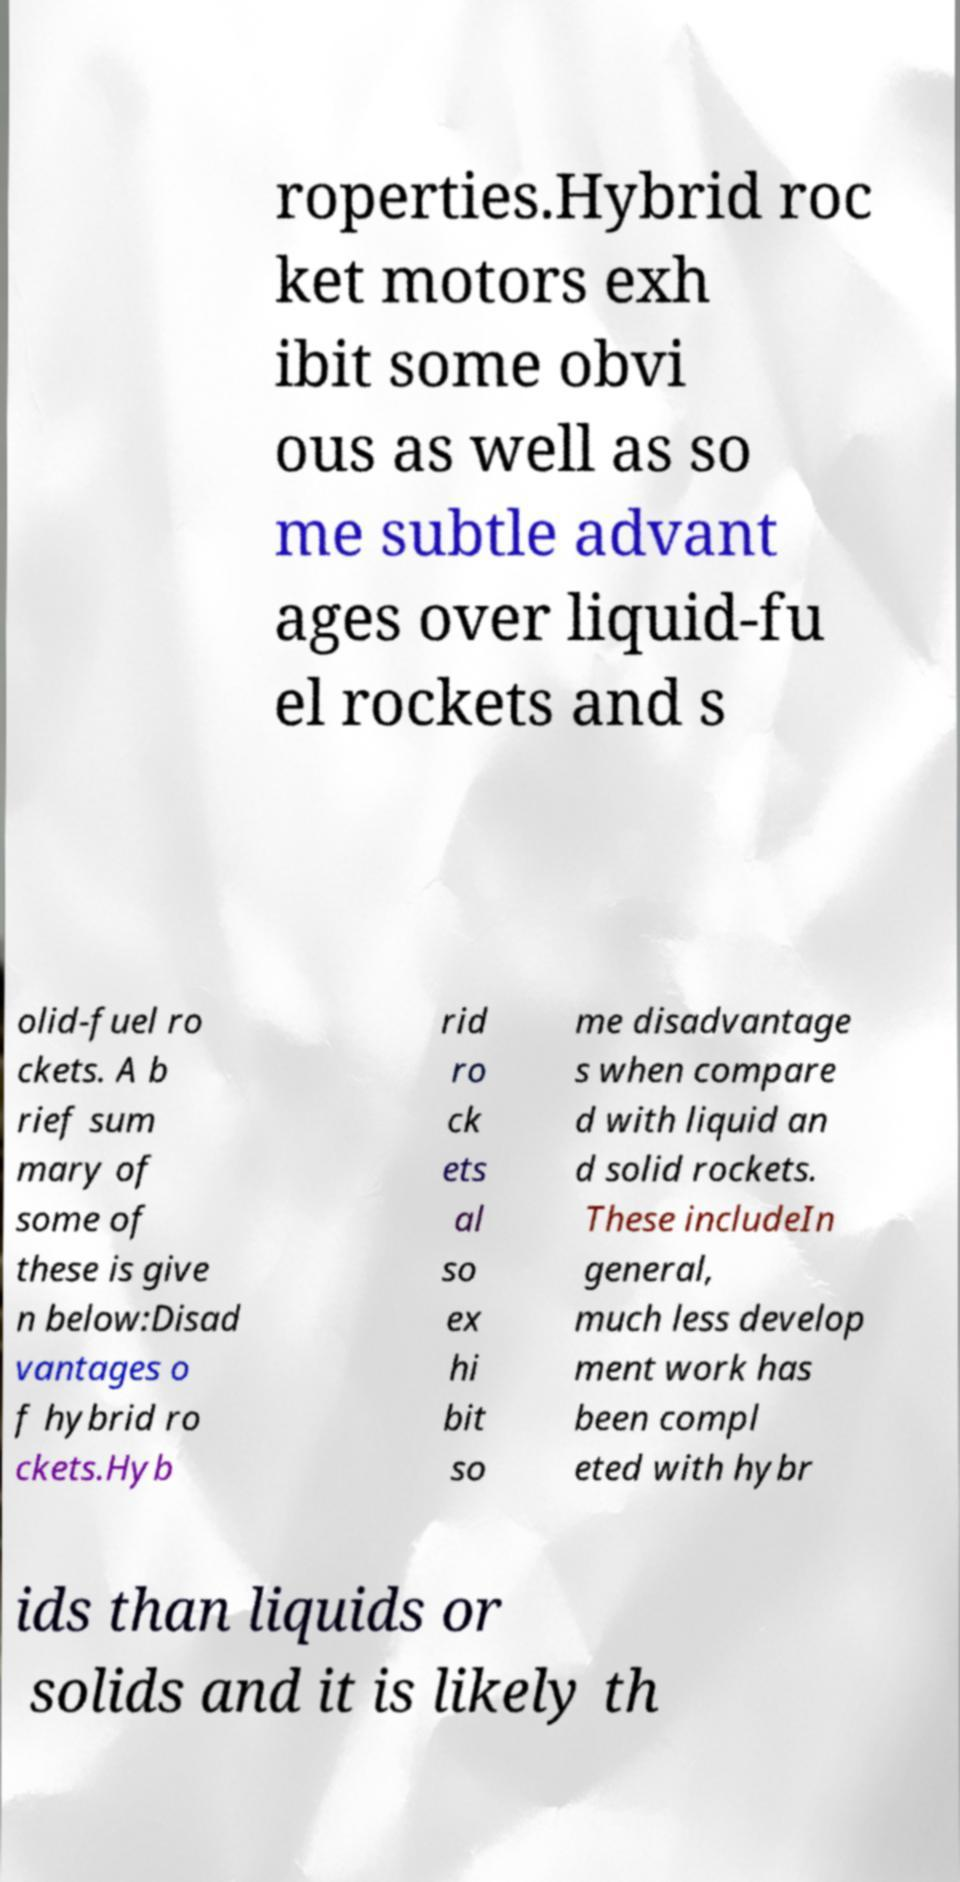Could you assist in decoding the text presented in this image and type it out clearly? roperties.Hybrid roc ket motors exh ibit some obvi ous as well as so me subtle advant ages over liquid-fu el rockets and s olid-fuel ro ckets. A b rief sum mary of some of these is give n below:Disad vantages o f hybrid ro ckets.Hyb rid ro ck ets al so ex hi bit so me disadvantage s when compare d with liquid an d solid rockets. These includeIn general, much less develop ment work has been compl eted with hybr ids than liquids or solids and it is likely th 